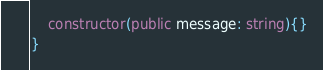Convert code to text. <code><loc_0><loc_0><loc_500><loc_500><_TypeScript_>    constructor(public message: string){}
}</code> 